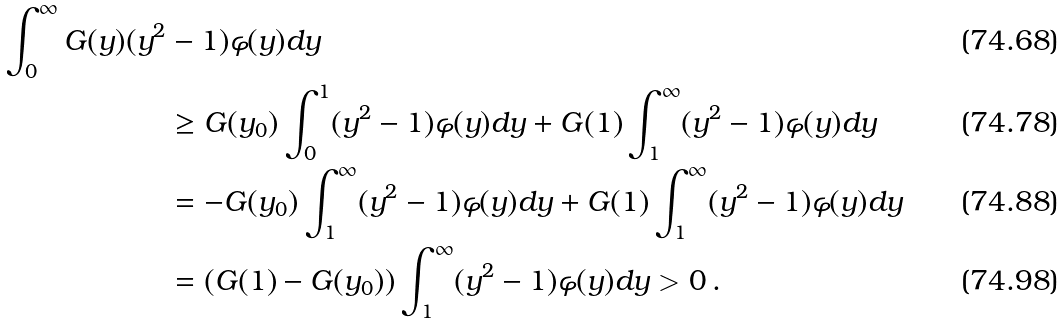<formula> <loc_0><loc_0><loc_500><loc_500>\int _ { 0 } ^ { \infty } G ( y ) ( y ^ { 2 } & - 1 ) \varphi ( y ) d y \\ & \geq G ( y _ { 0 } ) \int _ { 0 } ^ { 1 } ( y ^ { 2 } - 1 ) \varphi ( y ) d y + G ( 1 ) \int _ { 1 } ^ { \infty } ( y ^ { 2 } - 1 ) \varphi ( y ) d y \\ & = - G ( y _ { 0 } ) \int _ { 1 } ^ { \infty } ( y ^ { 2 } - 1 ) \varphi ( y ) d y + G ( 1 ) \int _ { 1 } ^ { \infty } ( y ^ { 2 } - 1 ) \varphi ( y ) d y \\ & = ( G ( 1 ) - G ( y _ { 0 } ) ) \int _ { 1 } ^ { \infty } ( y ^ { 2 } - 1 ) \varphi ( y ) d y > 0 \, .</formula> 